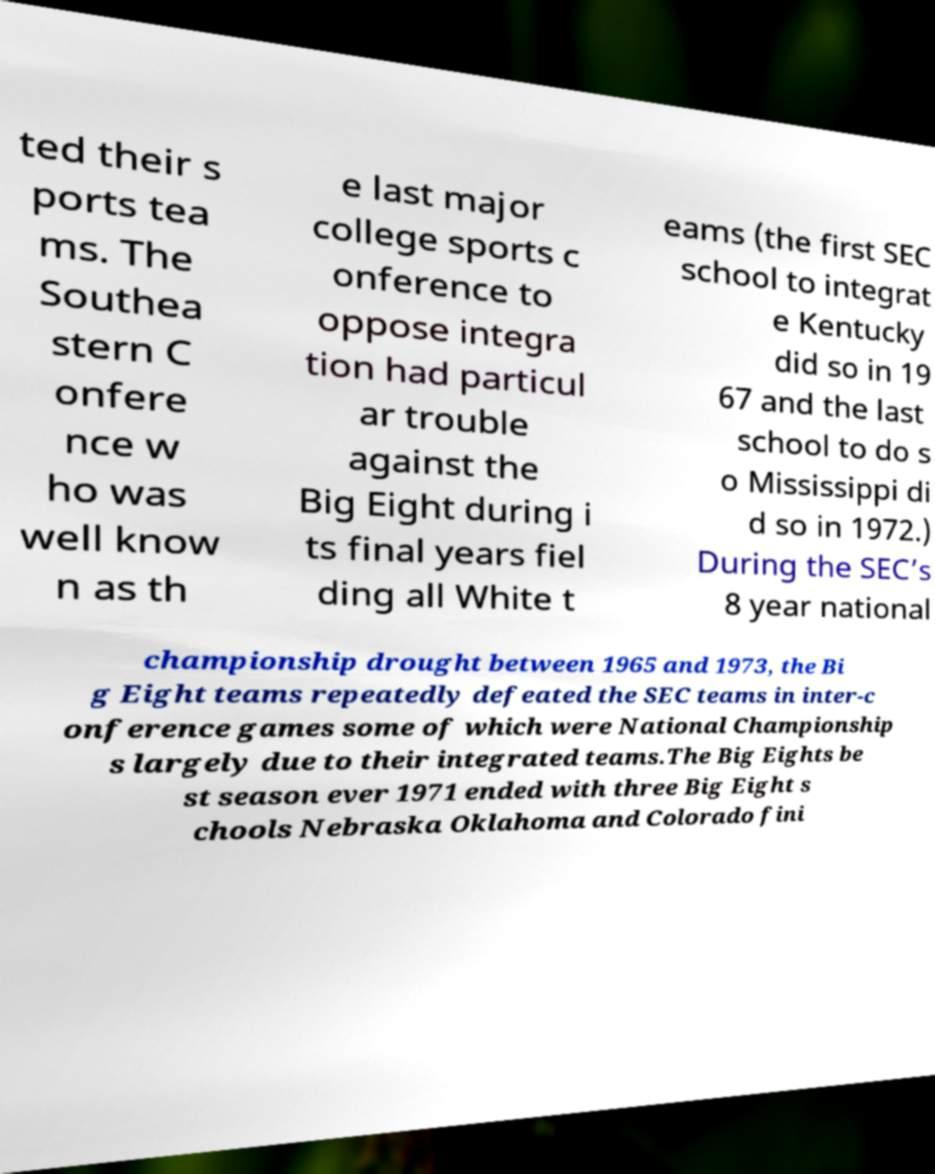What messages or text are displayed in this image? I need them in a readable, typed format. ted their s ports tea ms. The Southea stern C onfere nce w ho was well know n as th e last major college sports c onference to oppose integra tion had particul ar trouble against the Big Eight during i ts final years fiel ding all White t eams (the first SEC school to integrat e Kentucky did so in 19 67 and the last school to do s o Mississippi di d so in 1972.) During the SEC’s 8 year national championship drought between 1965 and 1973, the Bi g Eight teams repeatedly defeated the SEC teams in inter-c onference games some of which were National Championship s largely due to their integrated teams.The Big Eights be st season ever 1971 ended with three Big Eight s chools Nebraska Oklahoma and Colorado fini 